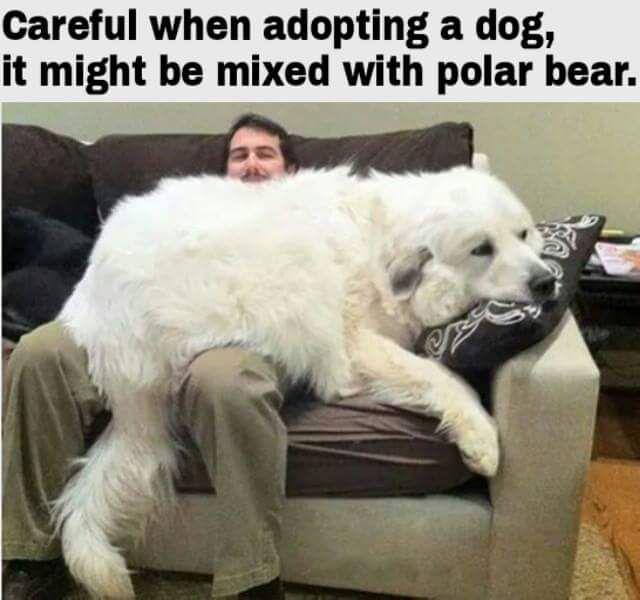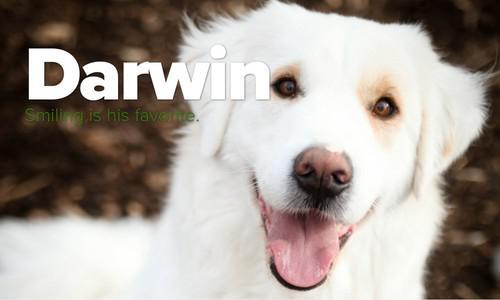The first image is the image on the left, the second image is the image on the right. Given the left and right images, does the statement "An image shows a white dog draped across seating furniture." hold true? Answer yes or no. Yes. The first image is the image on the left, the second image is the image on the right. Considering the images on both sides, is "In one image, a large white dog is lounging on a sofa, with its tail hanging over the front." valid? Answer yes or no. Yes. 